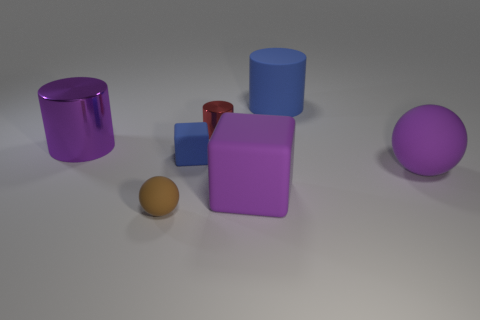Add 3 brown metallic things. How many objects exist? 10 Subtract all small red metal cylinders. How many cylinders are left? 2 Subtract all blue cubes. How many cubes are left? 1 Subtract all blocks. How many objects are left? 5 Subtract all rubber objects. Subtract all small brown matte balls. How many objects are left? 1 Add 7 big blue rubber things. How many big blue rubber things are left? 8 Add 5 brown balls. How many brown balls exist? 6 Subtract 0 gray cylinders. How many objects are left? 7 Subtract 1 balls. How many balls are left? 1 Subtract all brown spheres. Subtract all purple blocks. How many spheres are left? 1 